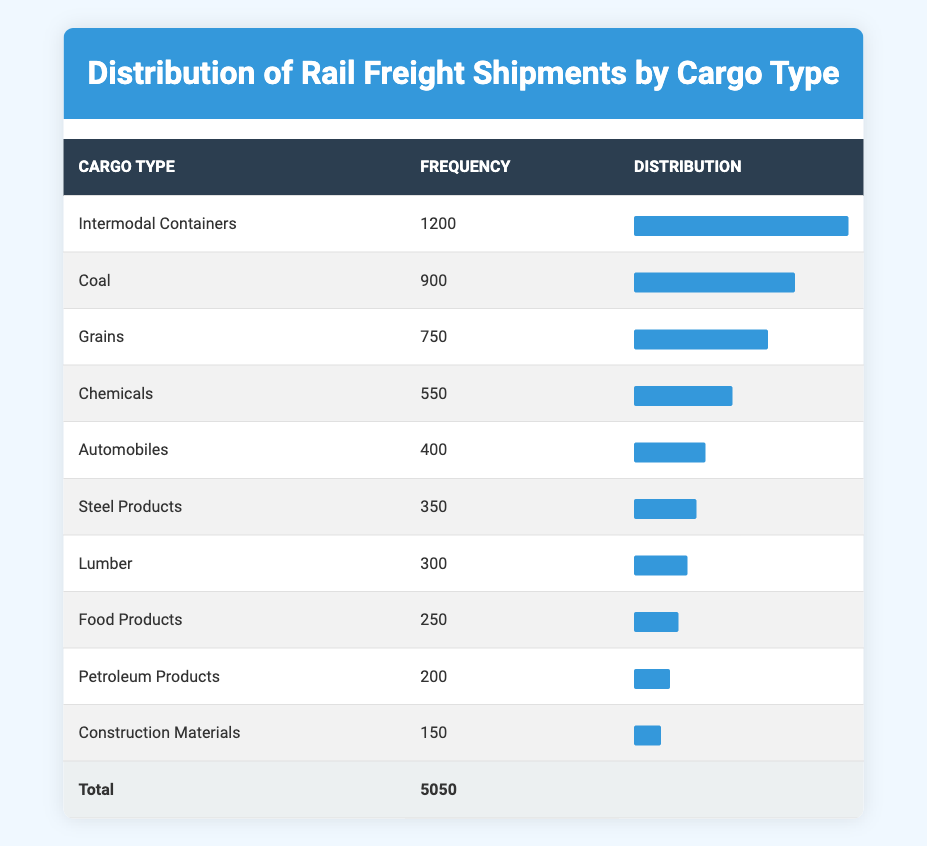What is the frequency of Coal shipments? In the table, the frequency listed for Coal shipments is directly provided in the frequency column.
Answer: 900 Which cargo type has the highest frequency? By examining the frequency column, Intermodal Containers show the highest value at 1200 shipments.
Answer: Intermodal Containers What is the total frequency of all cargo types combined? The total frequency is calculated by adding all the frequencies listed in the table. The frequencies are (1200 + 900 + 750 + 550 + 400 + 350 + 300 + 250 + 200 + 150) = 5050.
Answer: 5050 Is the frequency of Automobiles shipments greater than that of Steel Products? By comparing the two values, Automobiles have a frequency of 400 while Steel Products have 350. Since 400 is greater than 350, the answer is yes.
Answer: Yes What is the average frequency of the top three cargo types? The top three cargo types by frequency are Intermodal Containers (1200), Coal (900), and Grains (750). Summing these frequencies gives (1200 + 900 + 750) = 2850, and dividing by 3 gives an average of 2850 / 3 = 950.
Answer: 950 How many cargo types have a frequency greater than 500? Examining the table, we find that the following cargo types have frequencies greater than 500: Intermodal Containers (1200), Coal (900), and Chemicals (550). This makes a total of 3 cargo types.
Answer: 3 What is the difference in frequency between the highest and lowest cargo types? The highest cargo type, Intermodal Containers, has a frequency of 1200, while the lowest, Construction Materials, has 150. Finding the difference gives 1200 - 150 = 1050.
Answer: 1050 Are more shipments moving as intermodal containers than petroleum products? Intermodal Containers have a frequency of 1200, while Petroleum Products have only 200. Since 1200 is greater than 200, the answer is yes.
Answer: Yes What is the combined frequency of food products and construction materials? Combining the frequencies, Food Products have 250, and Construction Materials have 150, summing them gives 250 + 150 = 400.
Answer: 400 